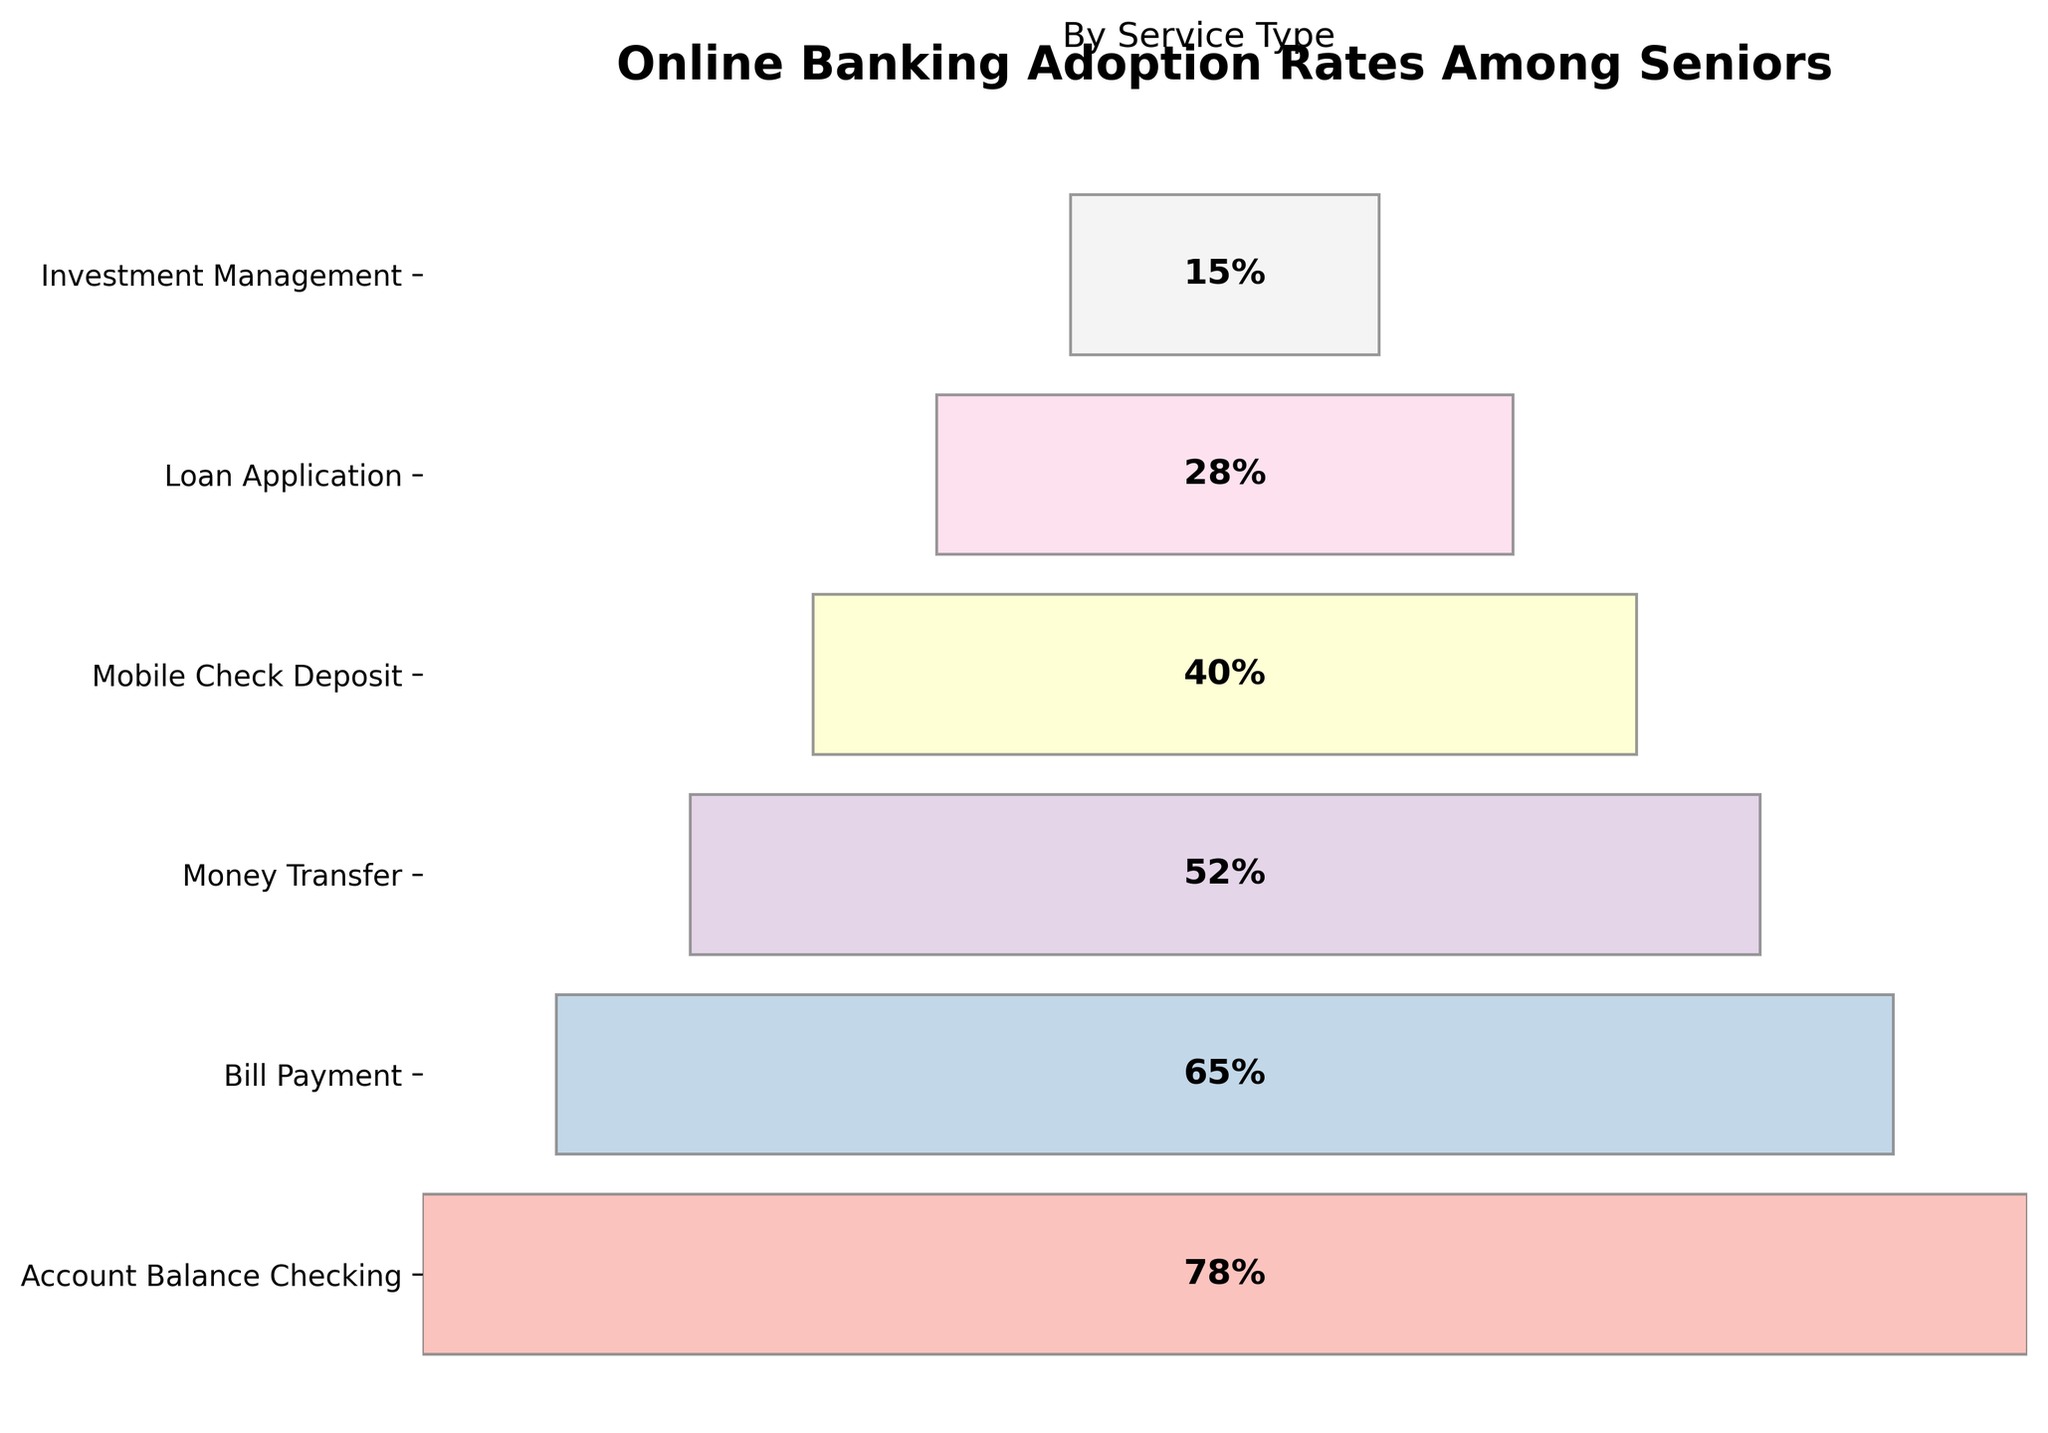What's the title of the Funnel Chart? The title is positioned at the top of the figure. The first line is bold and larger in font size, indicating the main title.
Answer: Online Banking Adoption Rates Among Seniors Which service type has the highest adoption rate among seniors? The top bar represents the service with the highest adoption rate, which is labeled on the y-axis.
Answer: Account Balance Checking What is the adoption rate for Bill Payment? The second bar from the top corresponds to Bill Payment, and the percentage is displayed inside the bar.
Answer: 65% How many service types have an adoption rate of more than 50%? Counting the bars with percentages greater than 50% reveals the total. The top three bars (Account Balance Checking, Bill Payment, and Money Transfer) meet this criterion.
Answer: 3 Which service type shows the lowest adoption rate among seniors, and what is its rate? The bottom bar represents the service type with the lowest rate.
Answer: Investment Management, 15% What is the difference in adoption rates between Mobile Check Deposit and Loan Application? Subtract the adoption rate of Loan Application from that of Mobile Check Deposit. The rates are 40% and 28%, respectively. 40 - 28 = 12
Answer: 12% Which service type has an adoption rate closest to 50%? The bar that visually aligns closest to the 50% mark is identified. Money Transfer's adoption rate is 52%, which is closest to 50%.
Answer: Money Transfer Arrange the service types in descending order of adoption rates. List the service types starting with the highest rate and ending with the lowest, based on the bar heights.
Answer: Account Balance Checking, Bill Payment, Money Transfer, Mobile Check Deposit, Loan Application, Investment Management 